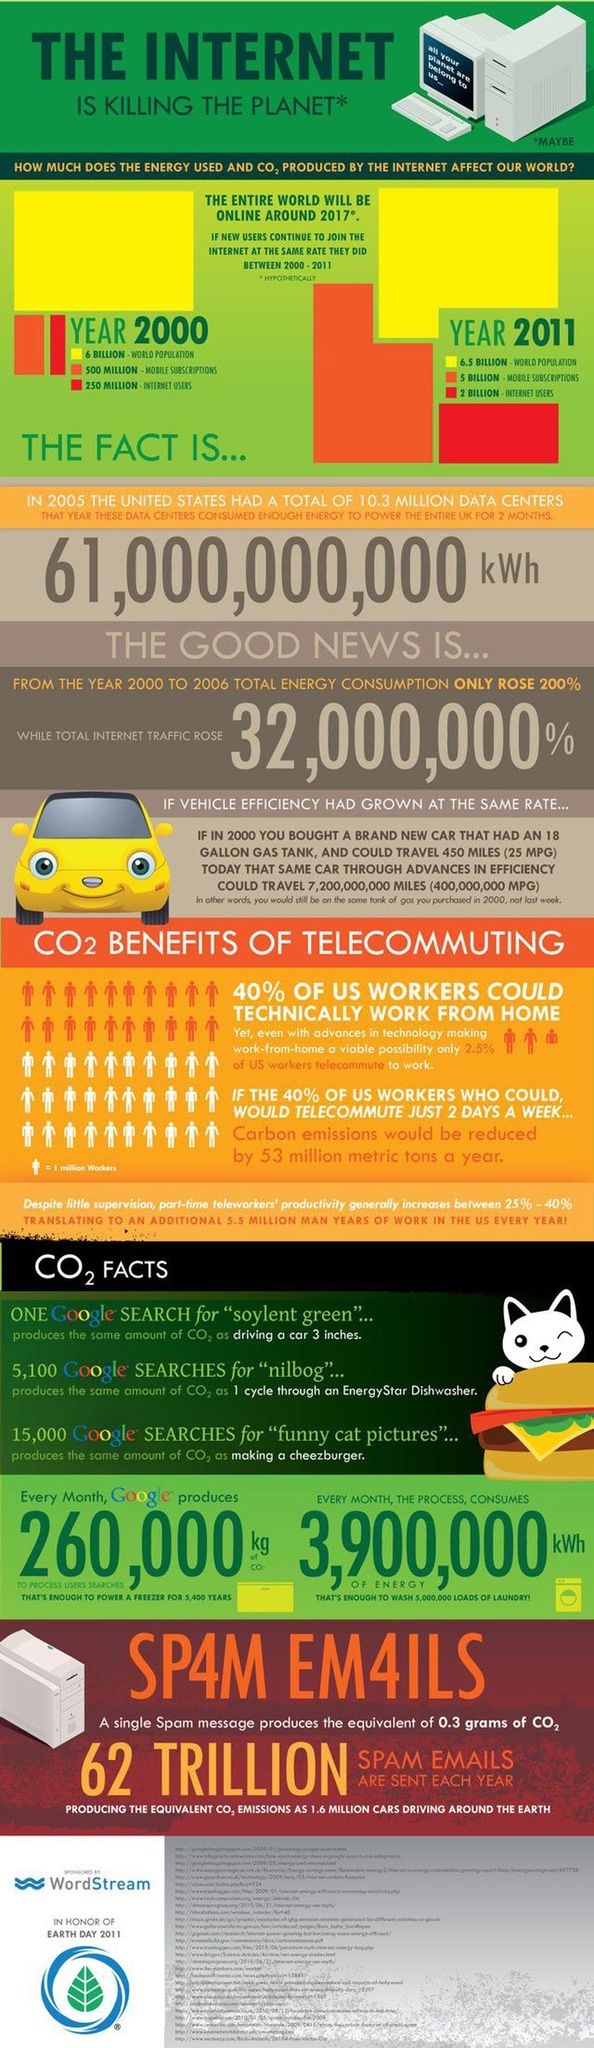What percentage of U.S workers are not working from home?
Answer the question with a short phrase. 60% What is the difference between the world population in 2011 and 2000? 0.5 Billion What is the total mobile subscription and internet users, taken together? 750 Million 